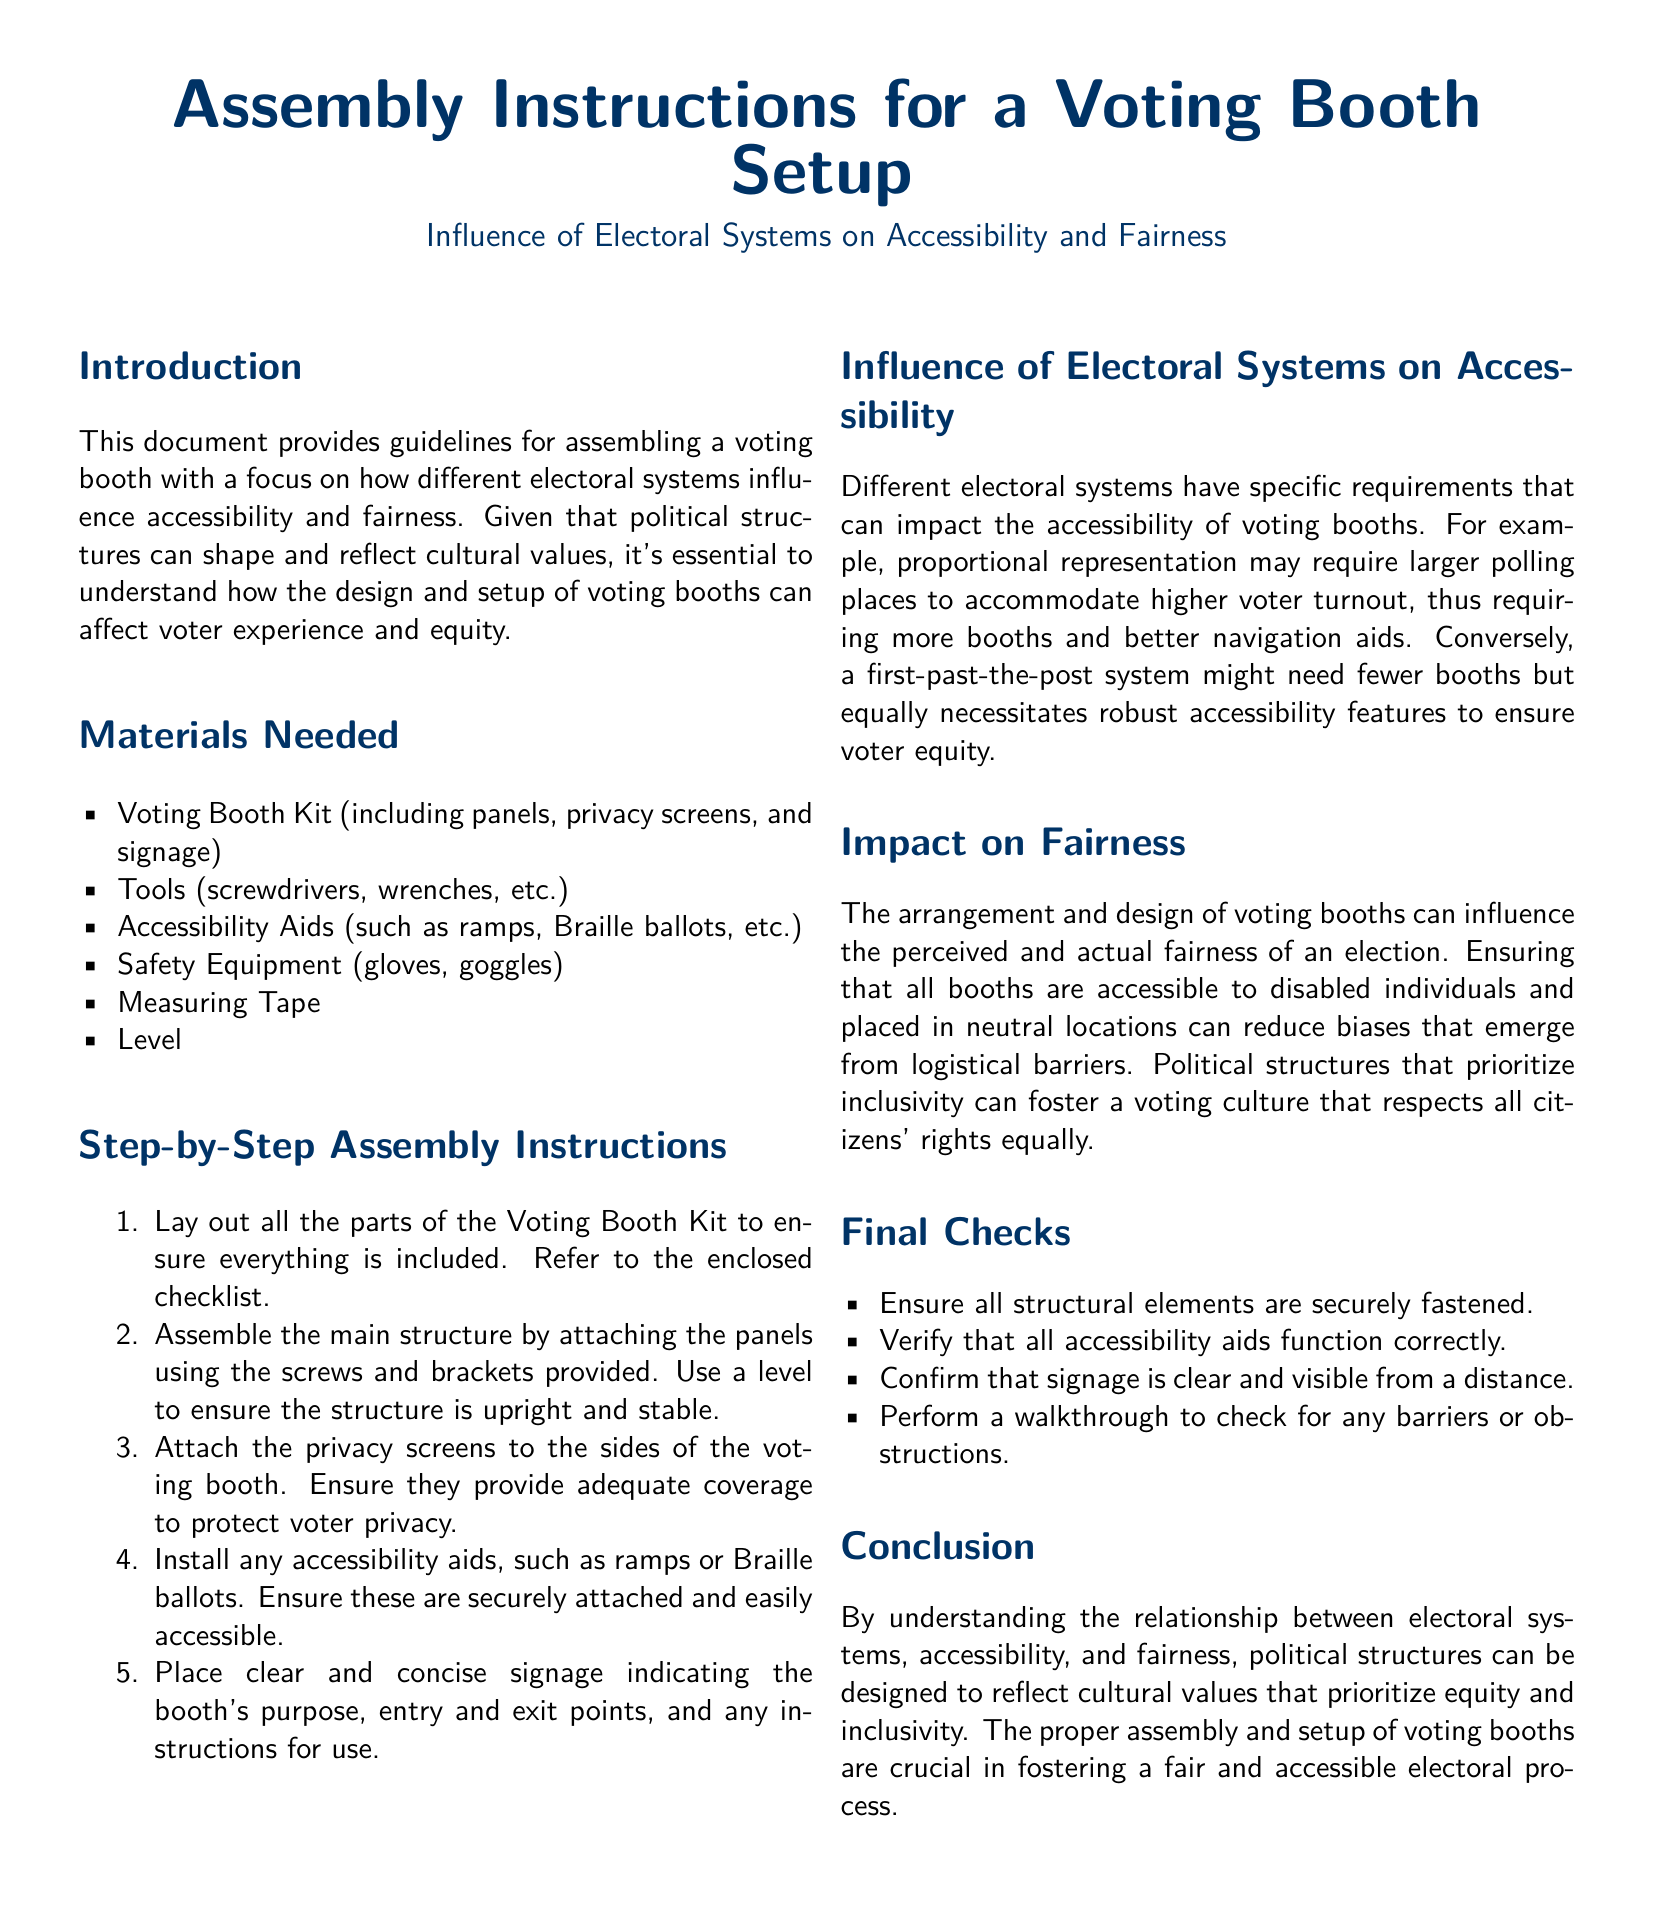What is the main focus of the assembly instructions? The document focuses on how different electoral systems influence accessibility and fairness in voting booth setups.
Answer: accessibility and fairness What materials are needed for assembly? The document lists various materials required for the assembly process, such as voting booth kit and tools.
Answer: Voting Booth Kit, Tools, Accessibility Aids How many steps are there in the assembly instructions? The document outlines a specific number of steps in the assembly process.
Answer: five What should be installed to improve accessibility? The document mentions specific aids that enhance accessibility in the voting booth setup.
Answer: ramps, Braille ballots Why is it important to ensure voting booths are accessible? The document explains the impact of booth accessibility on inclusivity and voter equity.
Answer: to foster a voting culture that respects all citizens' rights equally Which electoral system may require larger polling places? The document indicates a specific system that necessitates larger facilities for voter accommodation.
Answer: proportional representation What is highlighted in the final checks section? The final checks emphasize verifying various aspects to ensure booth quality and safety.
Answer: structural elements, accessibility aids, signage What can reduce biases in the electoral process? The document discusses arrangements that can mitigate biases stemming from logistical barriers.
Answer: neutral locations What is the document type? The document provides a specific guideline format for setting up a voting booth.
Answer: Assembly Instructions 